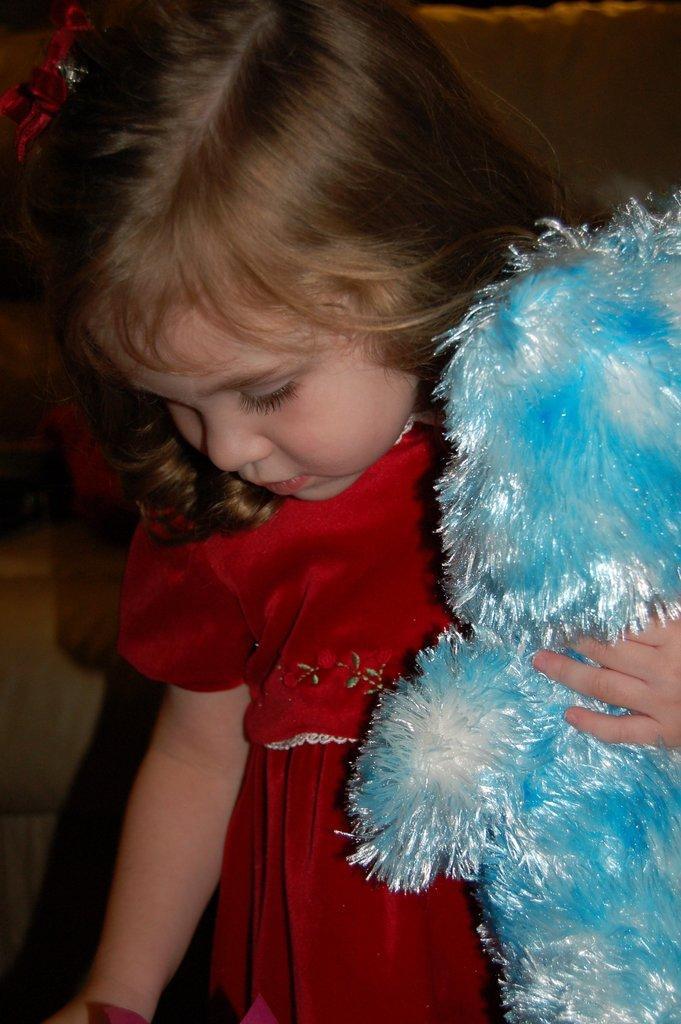How would you summarize this image in a sentence or two? In this image I can see the child holding the toy. The child is wearing the red color dress and the toy is in white and blue color. 